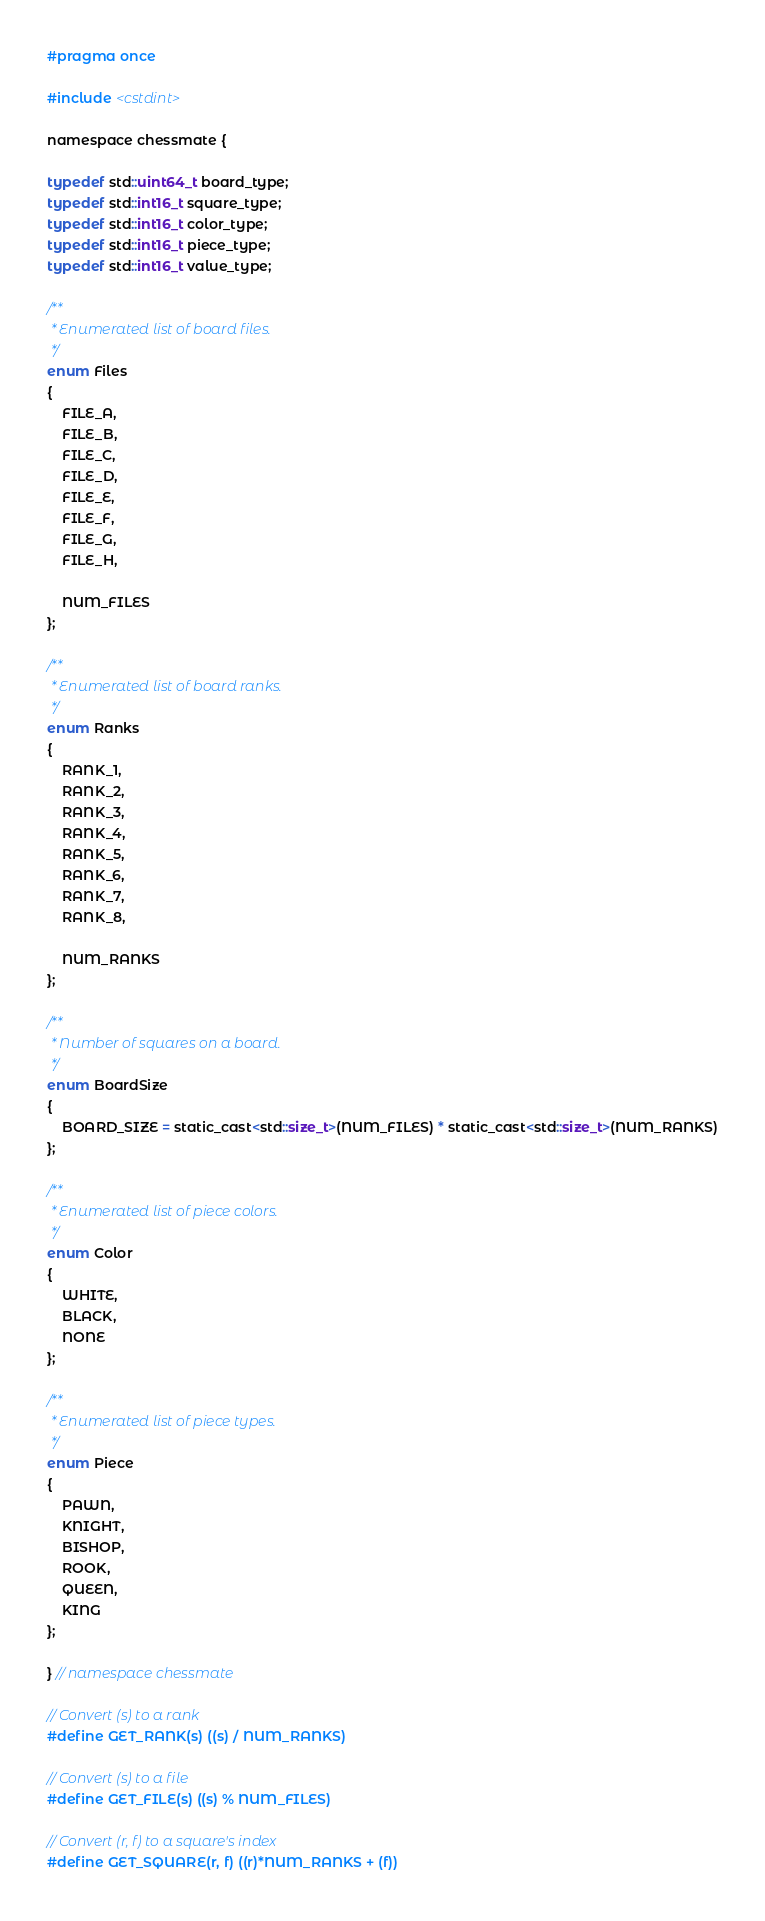Convert code to text. <code><loc_0><loc_0><loc_500><loc_500><_C_>#pragma once

#include <cstdint>

namespace chessmate {

typedef std::uint64_t board_type;
typedef std::int16_t square_type;
typedef std::int16_t color_type;
typedef std::int16_t piece_type;
typedef std::int16_t value_type;

/**
 * Enumerated list of board files.
 */
enum Files
{
    FILE_A,
    FILE_B,
    FILE_C,
    FILE_D,
    FILE_E,
    FILE_F,
    FILE_G,
    FILE_H,

    NUM_FILES
};

/**
 * Enumerated list of board ranks.
 */
enum Ranks
{
    RANK_1,
    RANK_2,
    RANK_3,
    RANK_4,
    RANK_5,
    RANK_6,
    RANK_7,
    RANK_8,

    NUM_RANKS
};

/**
 * Number of squares on a board.
 */
enum BoardSize
{
    BOARD_SIZE = static_cast<std::size_t>(NUM_FILES) * static_cast<std::size_t>(NUM_RANKS)
};

/**
 * Enumerated list of piece colors.
 */
enum Color
{
    WHITE,
    BLACK,
    NONE
};

/**
 * Enumerated list of piece types.
 */
enum Piece
{
    PAWN,
    KNIGHT,
    BISHOP,
    ROOK,
    QUEEN,
    KING
};

} // namespace chessmate

// Convert (s) to a rank
#define GET_RANK(s) ((s) / NUM_RANKS)

// Convert (s) to a file
#define GET_FILE(s) ((s) % NUM_FILES)

// Convert (r, f) to a square's index
#define GET_SQUARE(r, f) ((r)*NUM_RANKS + (f))
</code> 